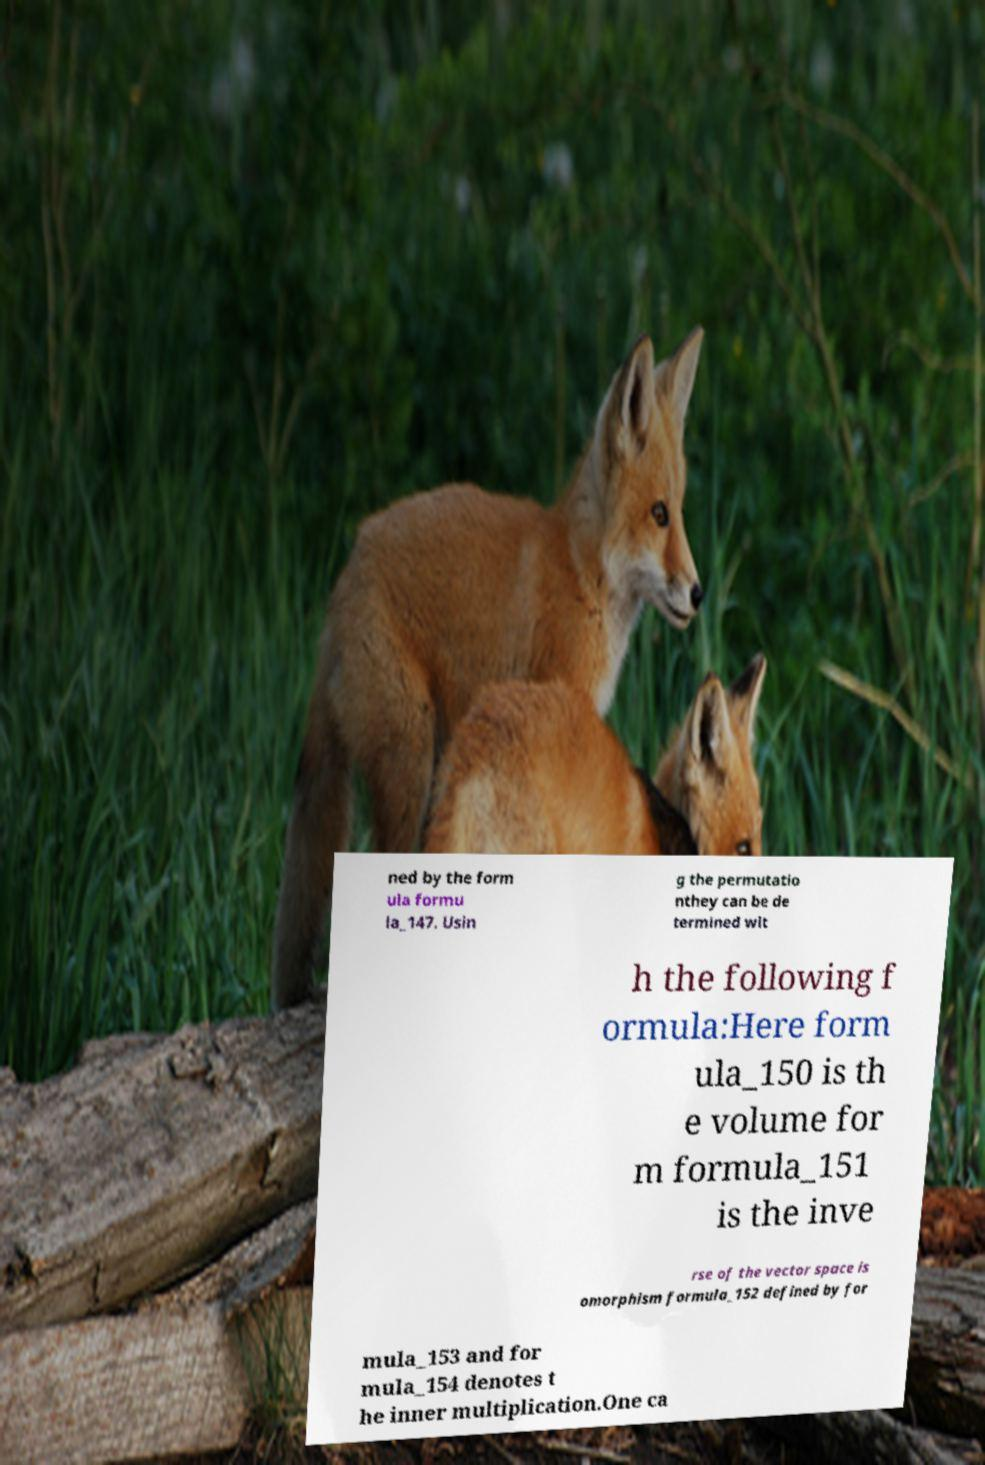Please identify and transcribe the text found in this image. ned by the form ula formu la_147. Usin g the permutatio nthey can be de termined wit h the following f ormula:Here form ula_150 is th e volume for m formula_151 is the inve rse of the vector space is omorphism formula_152 defined by for mula_153 and for mula_154 denotes t he inner multiplication.One ca 